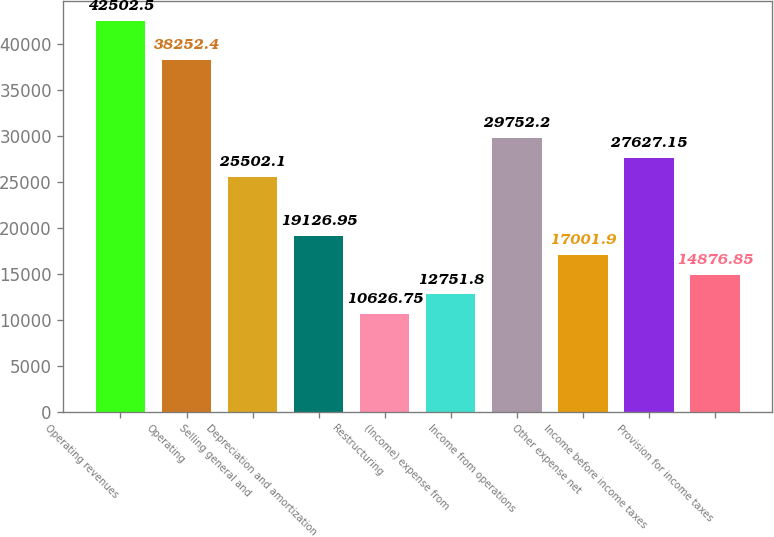<chart> <loc_0><loc_0><loc_500><loc_500><bar_chart><fcel>Operating revenues<fcel>Operating<fcel>Selling general and<fcel>Depreciation and amortization<fcel>Restructuring<fcel>(Income) expense from<fcel>Income from operations<fcel>Other expense net<fcel>Income before income taxes<fcel>Provision for income taxes<nl><fcel>42502.5<fcel>38252.4<fcel>25502.1<fcel>19127<fcel>10626.8<fcel>12751.8<fcel>29752.2<fcel>17001.9<fcel>27627.2<fcel>14876.9<nl></chart> 